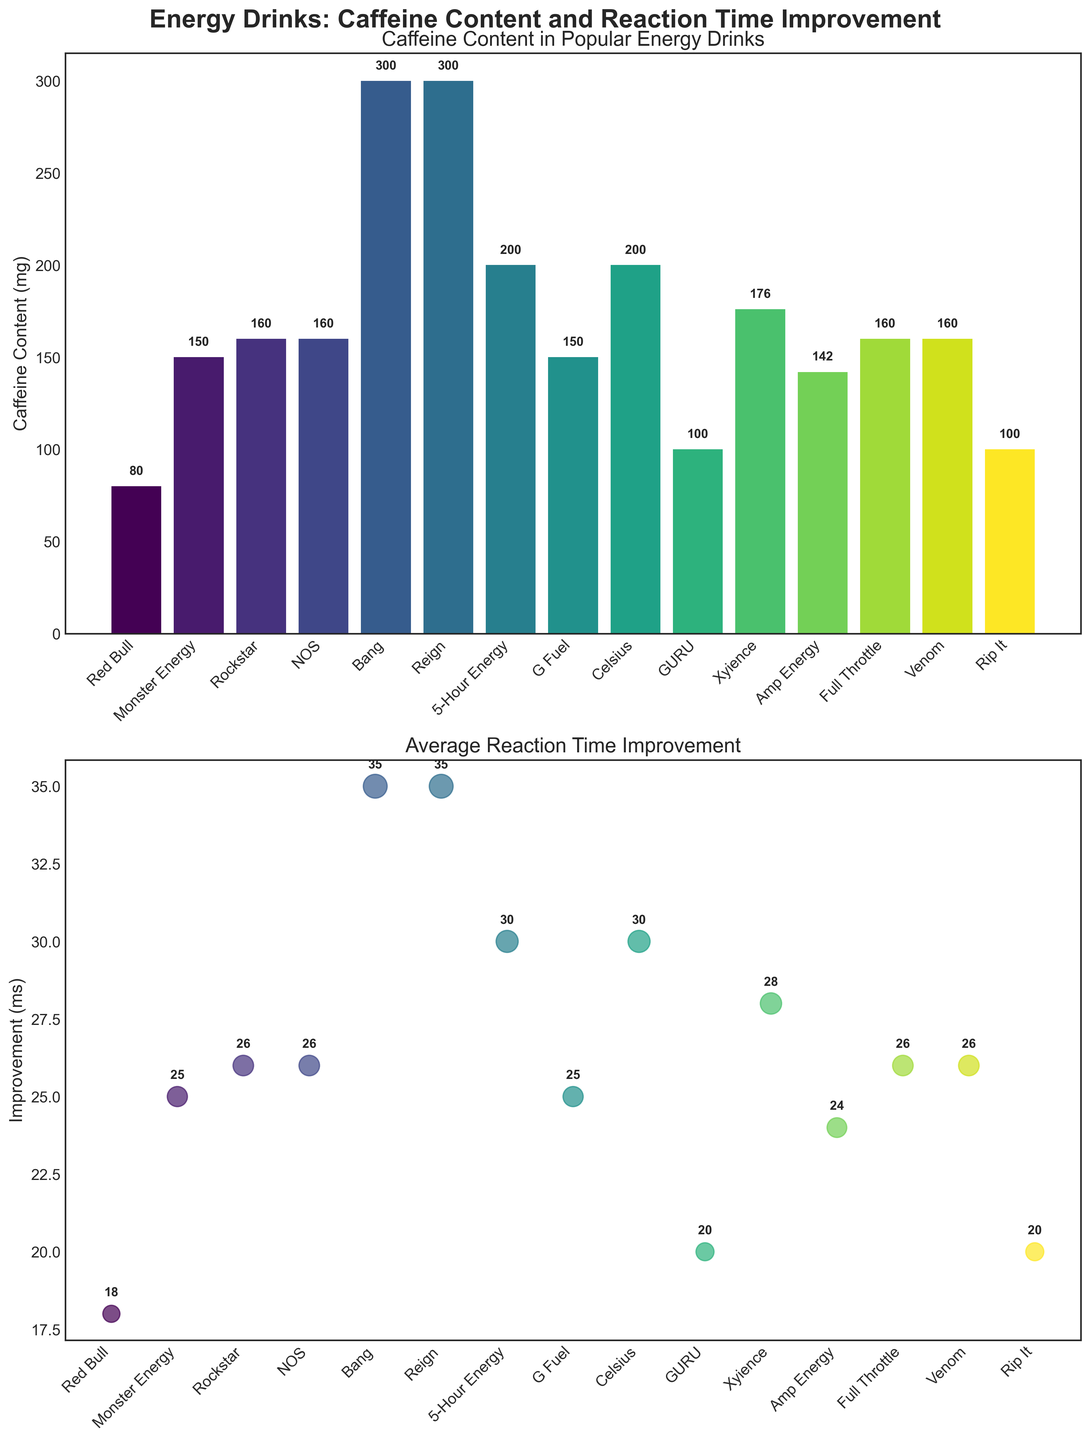Which energy drink has the highest caffeine content? The plot shows caffeine content in various energy drinks with bars of different heights. The highest bar represents Bang and Reign, which both show a caffeine content of 300 mg.
Answer: Bang and Reign What is the difference in average reaction time improvement between the drink with the lowest caffeine content and the one with the highest? The drink with the lowest caffeine content is Red Bull (80 mg) with an improvement of 18 ms, and the drink with the highest caffeine content is Bang and Reign (300 mg each) with an improvement of 35 ms. The difference is 35 - 18.
Answer: 17 ms How many energy drinks have a caffeine content above 150 mg? By looking at the bars, we can see that Monster Energy (150 mg), Rockstar (160 mg), NOS (160 mg), Bang (300 mg), Reign (300 mg), 5-Hour Energy (200 mg), Celsius (200 mg), Xyience (176 mg), Full Throttle (160 mg), Venom (160 mg) are above 150 mg. Counting these bars gives us the total.
Answer: 10 Which energy drink has the smallest improvement in reaction time? The scatter plot shows the improvement for each drink. The drink with the smallest number next to it is Red Bull, which shows an improvement of 18 ms.
Answer: Red Bull What's the average caffeine content among all the energy drinks? Sum all the caffeine content values and divide by the number of energy drinks: (80 + 150 + 160 + 160 + 300 + 300 + 200 + 150 + 200 + 100 + 176 + 142 + 160 + 160 + 100)/15. Calculating the sum and then the average.
Answer: 174.4 mg Which energy drink shows the largest bubble in the scatter plot? What does this indicate? The largest bubbles in the scatter plot are for Bang and Reign, indicating they have the highest average reaction time improvement of 35 ms.
Answer: Bang and Reign Is there any energy drink that has a reaction time improvement equal to 30 ms? From the scatter plot, the drinks with a 30 ms improvement are 5-Hour Energy and Celsius.
Answer: 5-Hour Energy and Celsius Compare the caffeine content of Rockstar and NOS. Which one has higher caffeine content? Both Rockstar and NOS have bars of the same height in the caffeine content plot, indicating they both have a caffeine content of 160 mg.
Answer: Equal 